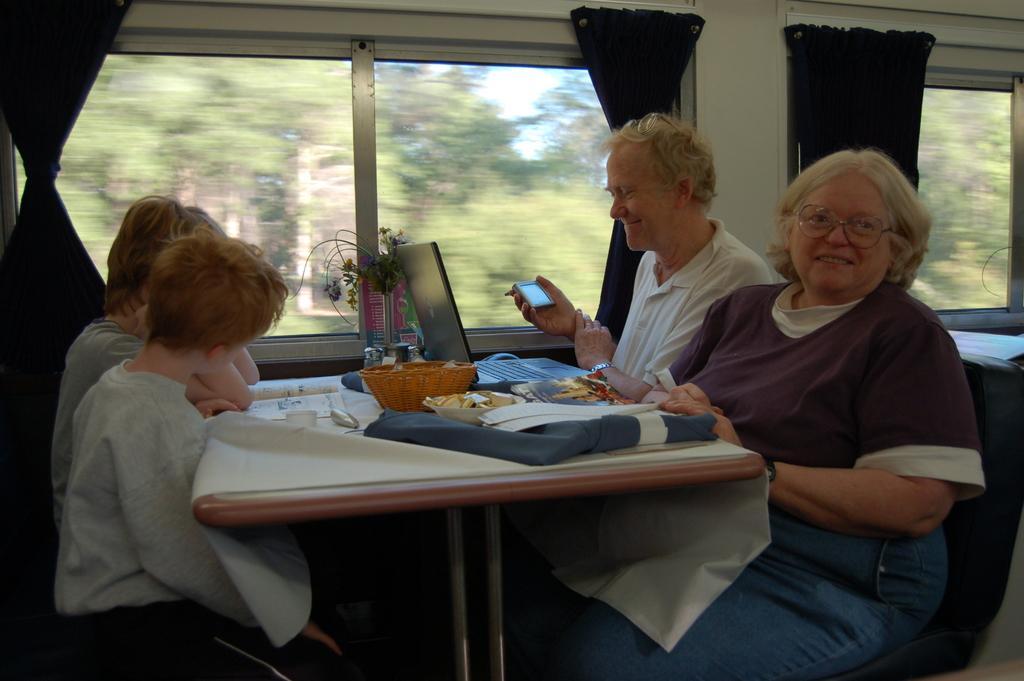Could you give a brief overview of what you see in this image? The image is taken inside a train. In the center of the image there is a table and there are people sitting around the table. There is a laptop, basket, some food, papers, a cloth which are placed on the table. In the background there is a window, a curtain. We can also see some trees outside the window. 